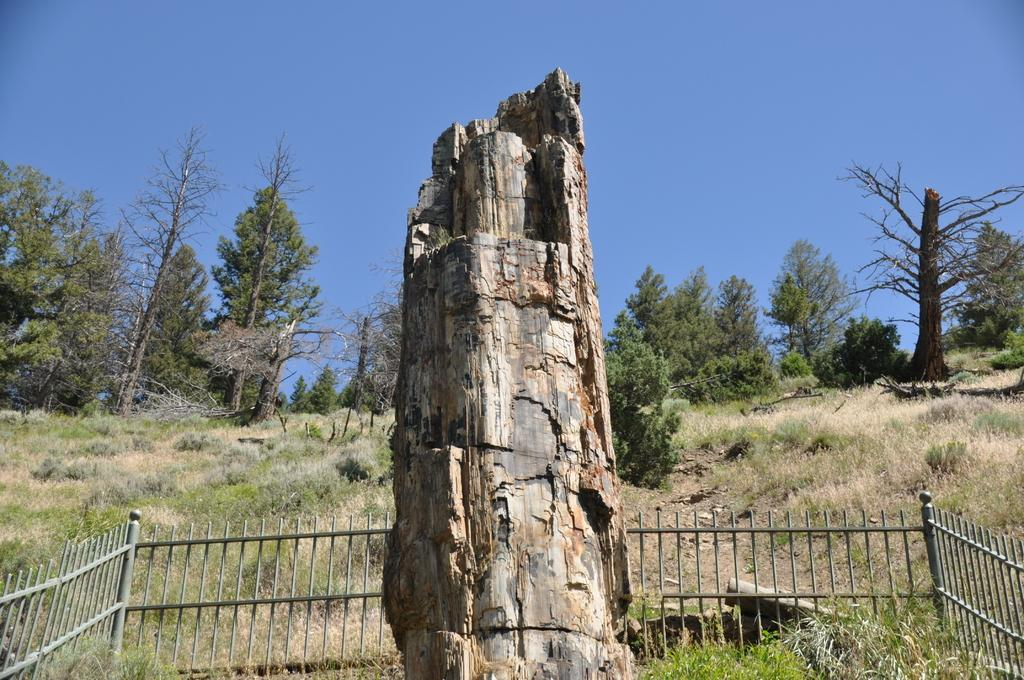What is the main object in the image? There is a tree trunk in the image. What else can be seen in the image besides the tree trunk? There is a fence, grass, and trees in the image. What is the color of the sky in the background of the image? The sky is blue in the background of the image. How many toes can be seen on the tree trunk in the image? There are no toes present in the image, as it features a tree trunk and other natural elements. 